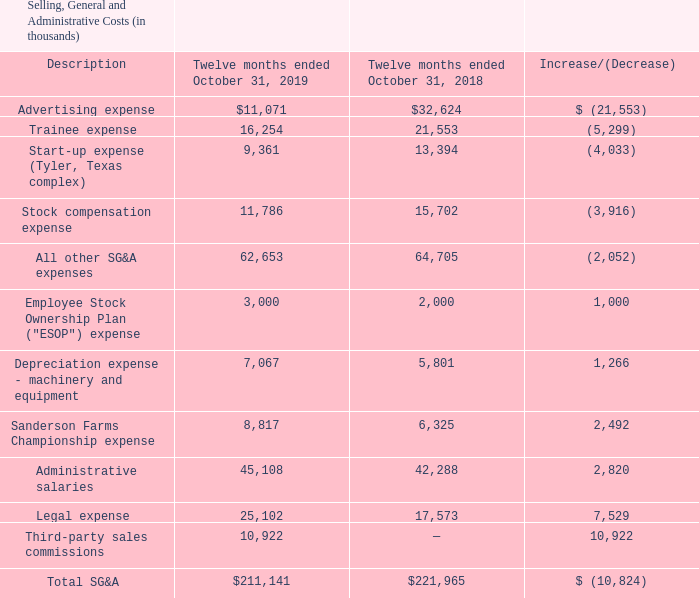Selling, general and administrative ("SG&A") costs during fiscal 2019 were $211.1 million, a decrease of $10.8 million compared to the $222.0 million of SG&A during fiscal 2018. The following table shows the components of SG&A costs for the twelve months ended October 31, 2019 and 2018.
Regarding the table above, the decrease in advertising expense is the result of the Company's decision to scale back its television and radio advertising during fiscal 2019. The change in start-up expense in any particular period relates to the stage of the start-up process in which a facility under construction is in during the period. Non-construction related expenses, such as labor, training and office-related expenses for a facility under construction are recorded as start-up expense until the facility begins operations. As a facility moves closer to actual start-up, the expenses incurred for labor, training, etc. increase. As a result, amounts classified as start-up expenses will increase period over period until the facility begins production. Once production begins, the expenses from that point forward are recorded as costs of goods sold. The decrease in stock compensation expense is the result of the number of shares earned for the performance shares granted on November 1, 2017, being lower as compared to the number of shares earned for the performance shares granted on November 1, 2016. Stock compensation is further described in "Part II, Item 8, Notes to Consolidated Financial Statements, Note 9 - Stock Compensation Plans." The increase in legal expenses is primarily attributable to our ongoing defense of the litigation described in "Part I, Item 3. Legal Proceedings" of this Form 10-K. The increase in third-party sales commissions is attributable to the Company's adoption of ASU 2014-09, Revenue from Contracts with Customers. While adoption of the standard had no effect on the Company's net income during fiscal 2019, SG&A expenses were negatively impacted during the period, and the negative impact to SG&A expenses was offset by a corresponding increase to revenue. For more information regarding the Company's adoption of ASU 2014-09 and the relation to SG&A expenses, refer to "Part II, Item 8, Notes to Consolidated Financial Statements, Note 1 - Significant Accounting Policies."
Why was there a decrease in advertising expense? Result of the company's decision to scale back its television and radio advertising during fiscal 2019. What was the total SG&A for fiscal 2019 and 2018 respectively?
Answer scale should be: thousand. $211,141, $221,965. What was the legal expense for fiscal 2019 and 2018 respectively?
Answer scale should be: thousand. 25,102, 17,573. What is the average legal expense for fiscal 2019 and 2018?
Answer scale should be: thousand. (25,102+17,573)/2
Answer: 21337.5. What is the average Administrative salaries for fiscal 2019 and 2018?
Answer scale should be: thousand. (45,108+42,288)/2
Answer: 43698. What is the average Advertising expense for fiscal 2019 and 2018?
Answer scale should be: thousand. (11,071+ 32,624)/2
Answer: 21847.5. 